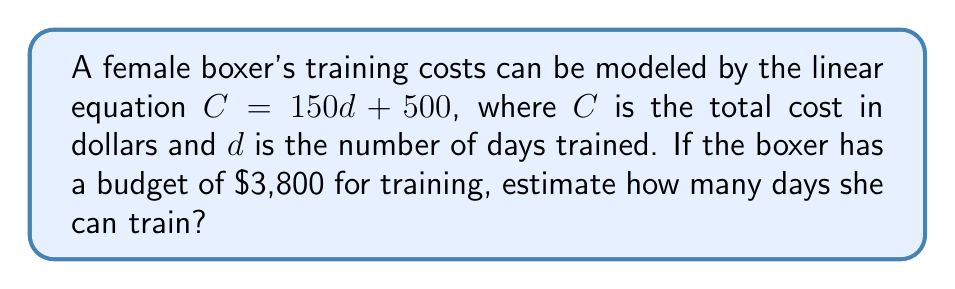Can you answer this question? Let's approach this step-by-step:

1) We're given the linear equation: $C = 150d + 500$

2) We know the boxer's budget is $3,800, so we can substitute this for $C$:

   $3800 = 150d + 500$

3) To solve for $d$, first subtract 500 from both sides:

   $3300 = 150d$

4) Now divide both sides by 150:

   $\frac{3300}{150} = d$

5) Simplify:

   $22 = d$

Therefore, the boxer can train for 22 days within her budget.
Answer: 22 days 